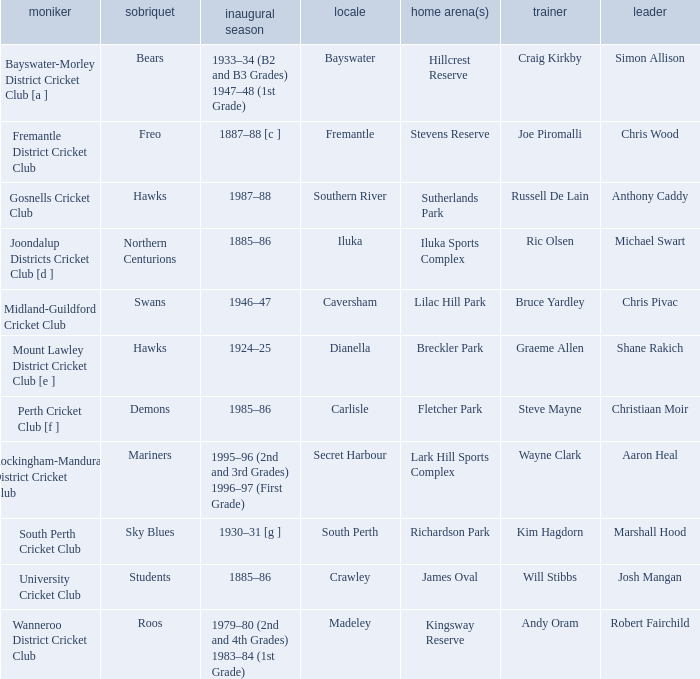With the nickname the swans, what is the home ground? Lilac Hill Park. 